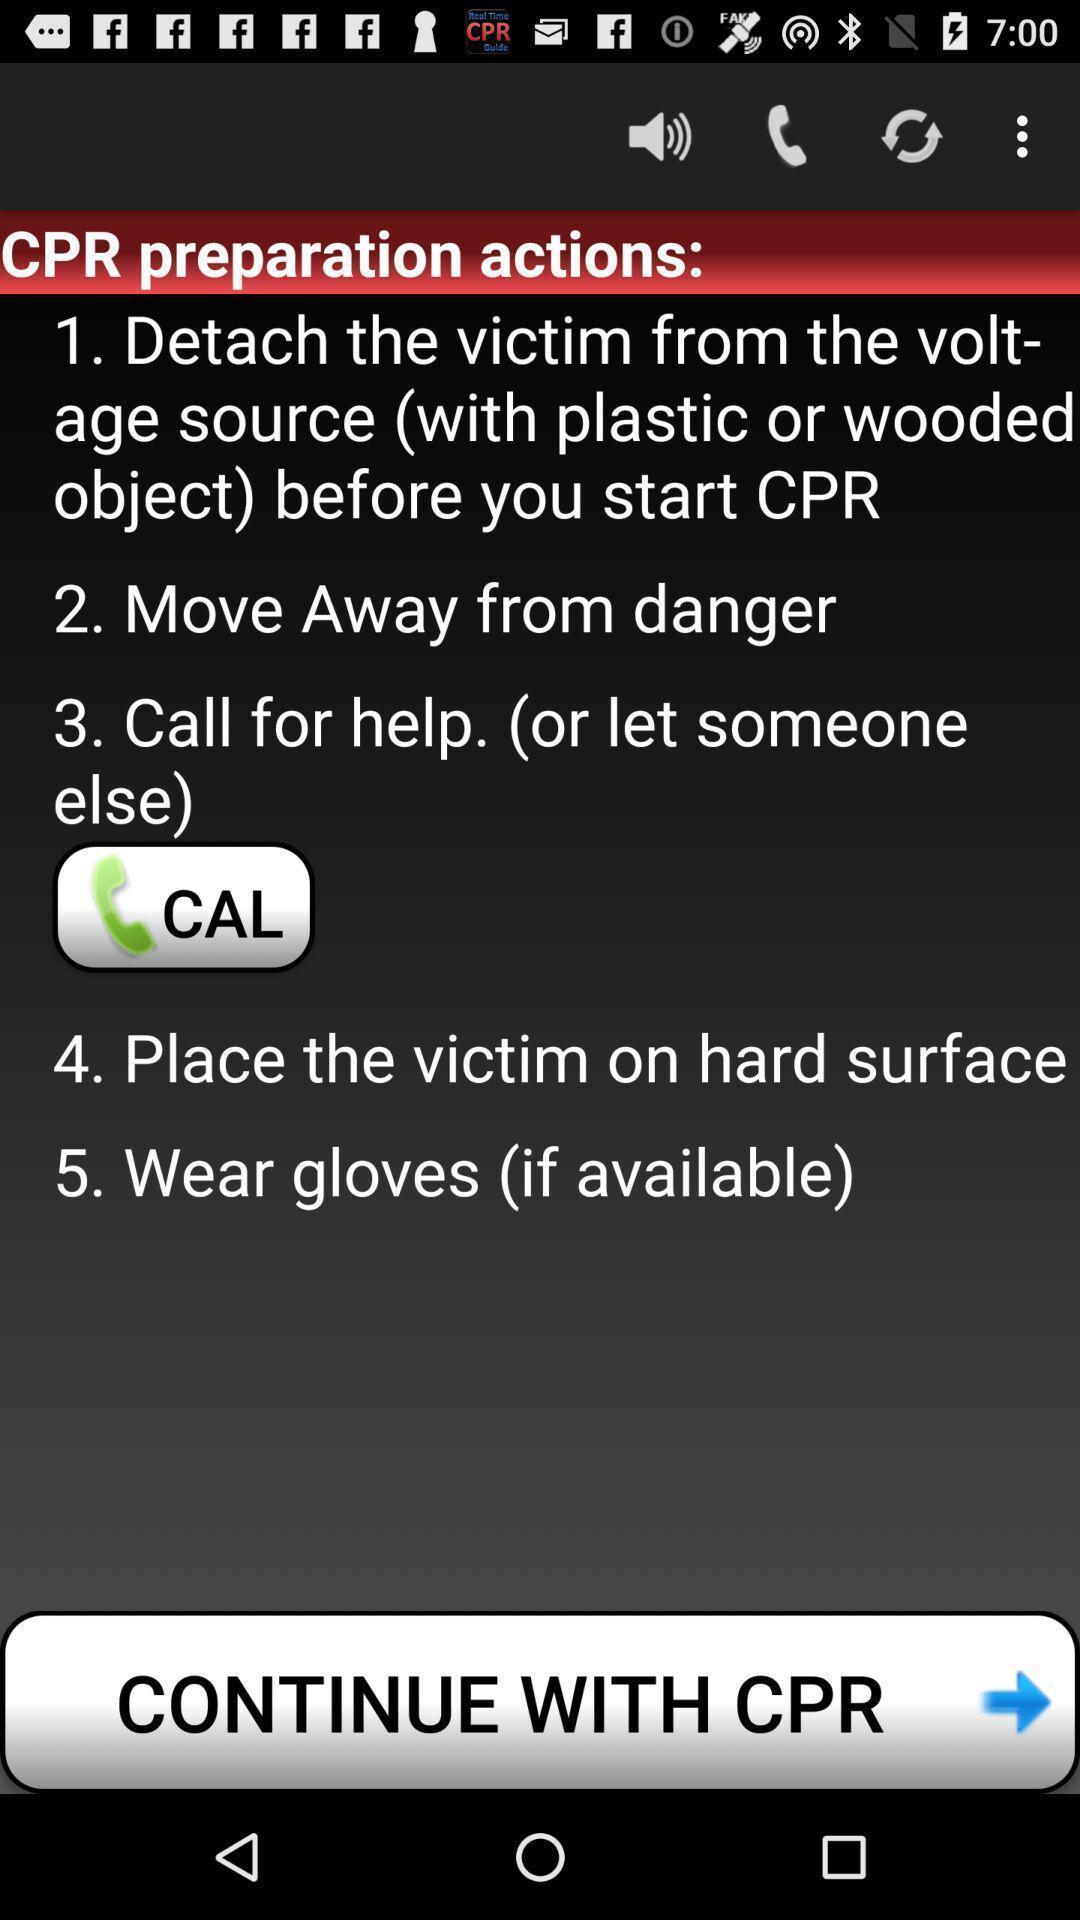Please provide a description for this image. Window displaying steps for guiding. 